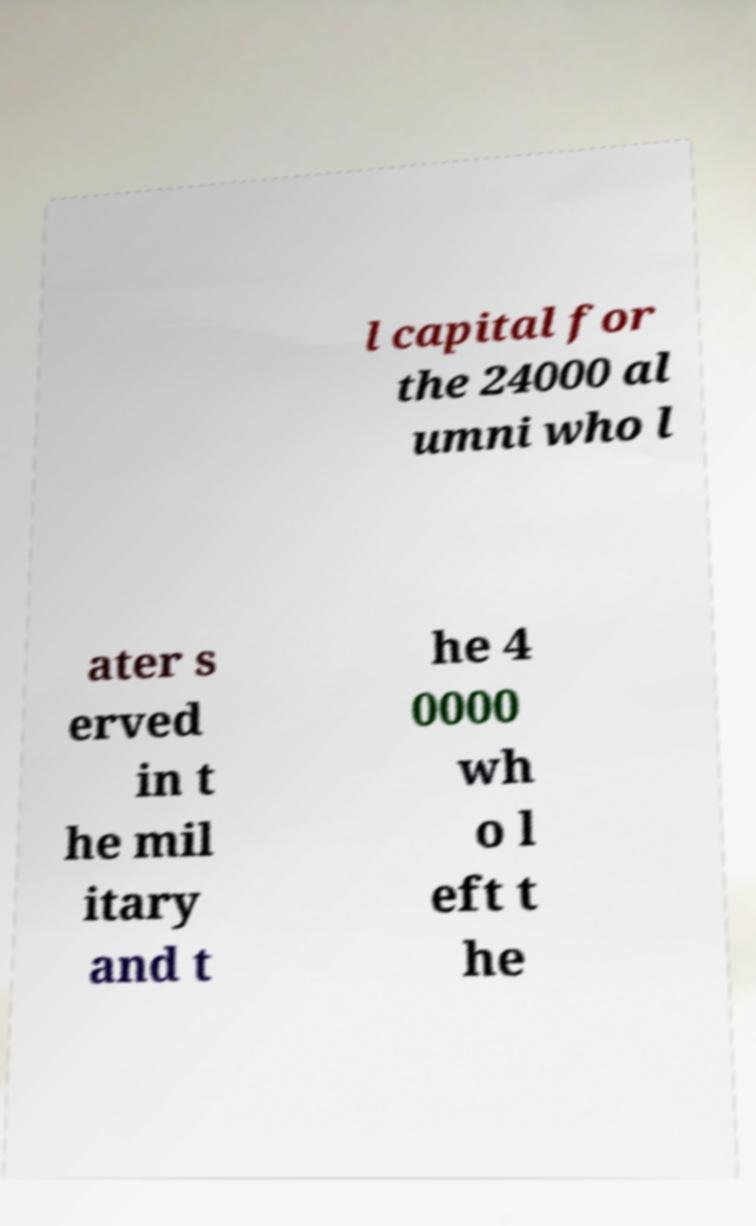There's text embedded in this image that I need extracted. Can you transcribe it verbatim? l capital for the 24000 al umni who l ater s erved in t he mil itary and t he 4 0000 wh o l eft t he 